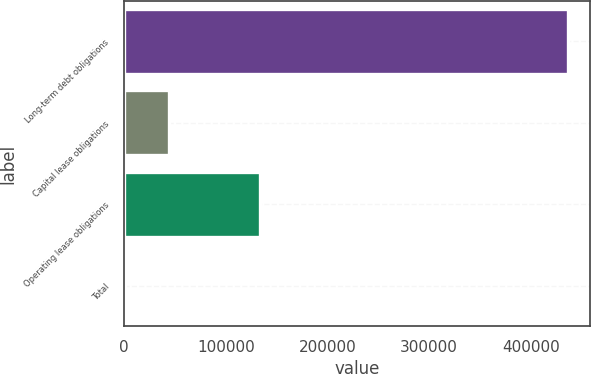Convert chart. <chart><loc_0><loc_0><loc_500><loc_500><bar_chart><fcel>Long-term debt obligations<fcel>Capital lease obligations<fcel>Operating lease obligations<fcel>Total<nl><fcel>436700<fcel>44186.4<fcel>133966<fcel>573.77<nl></chart> 